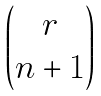Convert formula to latex. <formula><loc_0><loc_0><loc_500><loc_500>\begin{pmatrix} r \\ n + 1 \end{pmatrix}</formula> 